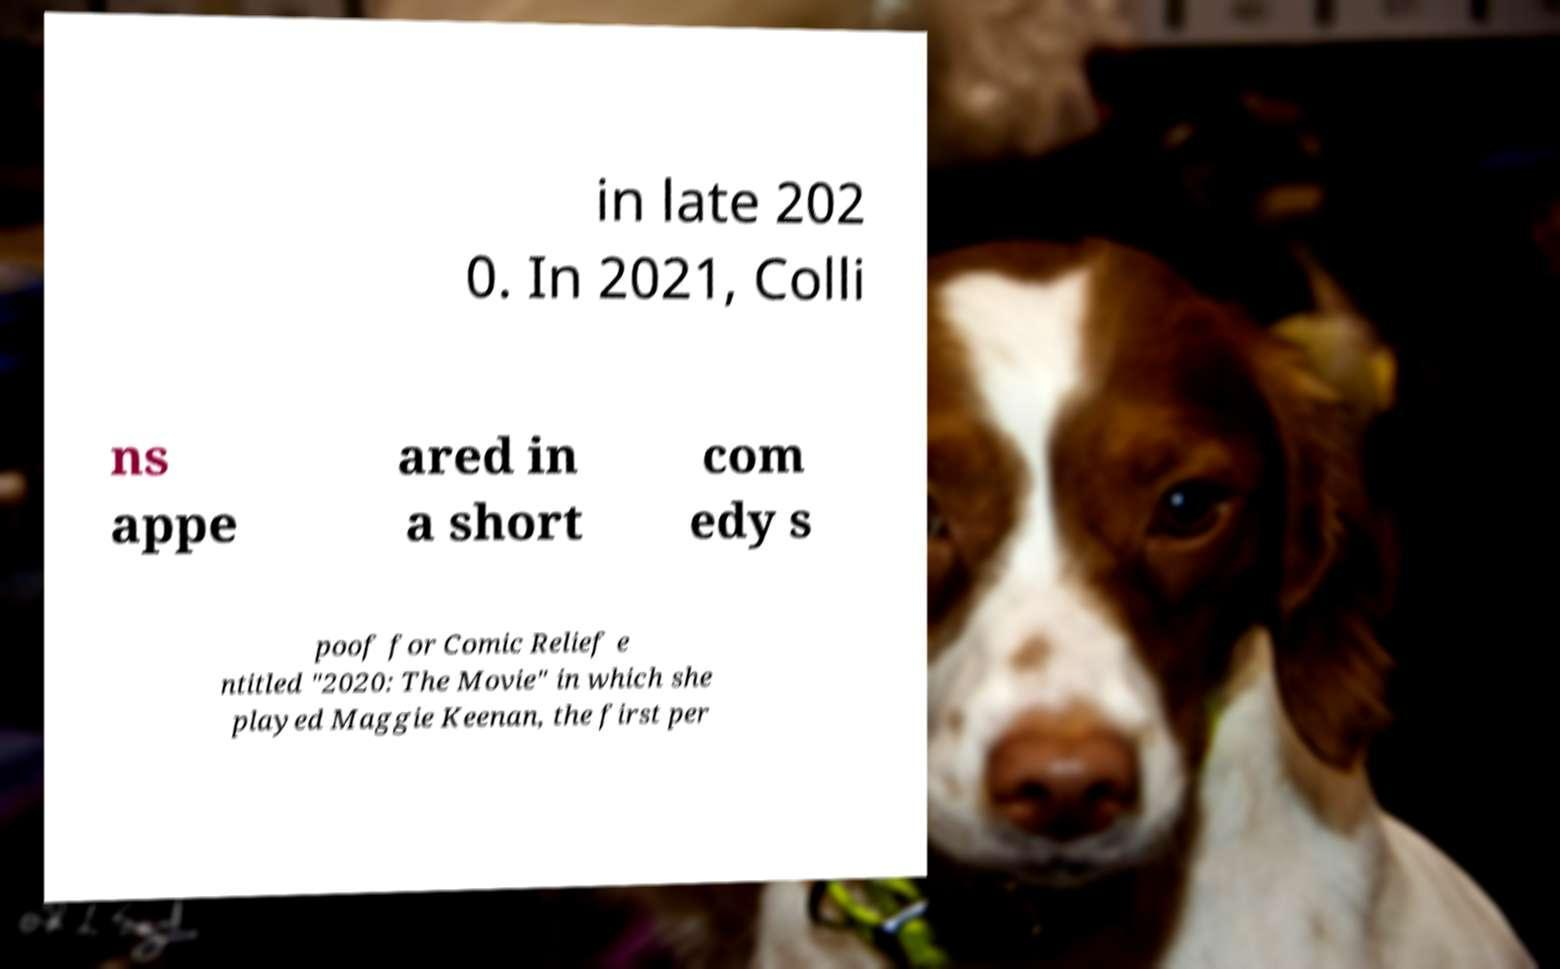Please read and relay the text visible in this image. What does it say? in late 202 0. In 2021, Colli ns appe ared in a short com edy s poof for Comic Relief e ntitled "2020: The Movie" in which she played Maggie Keenan, the first per 